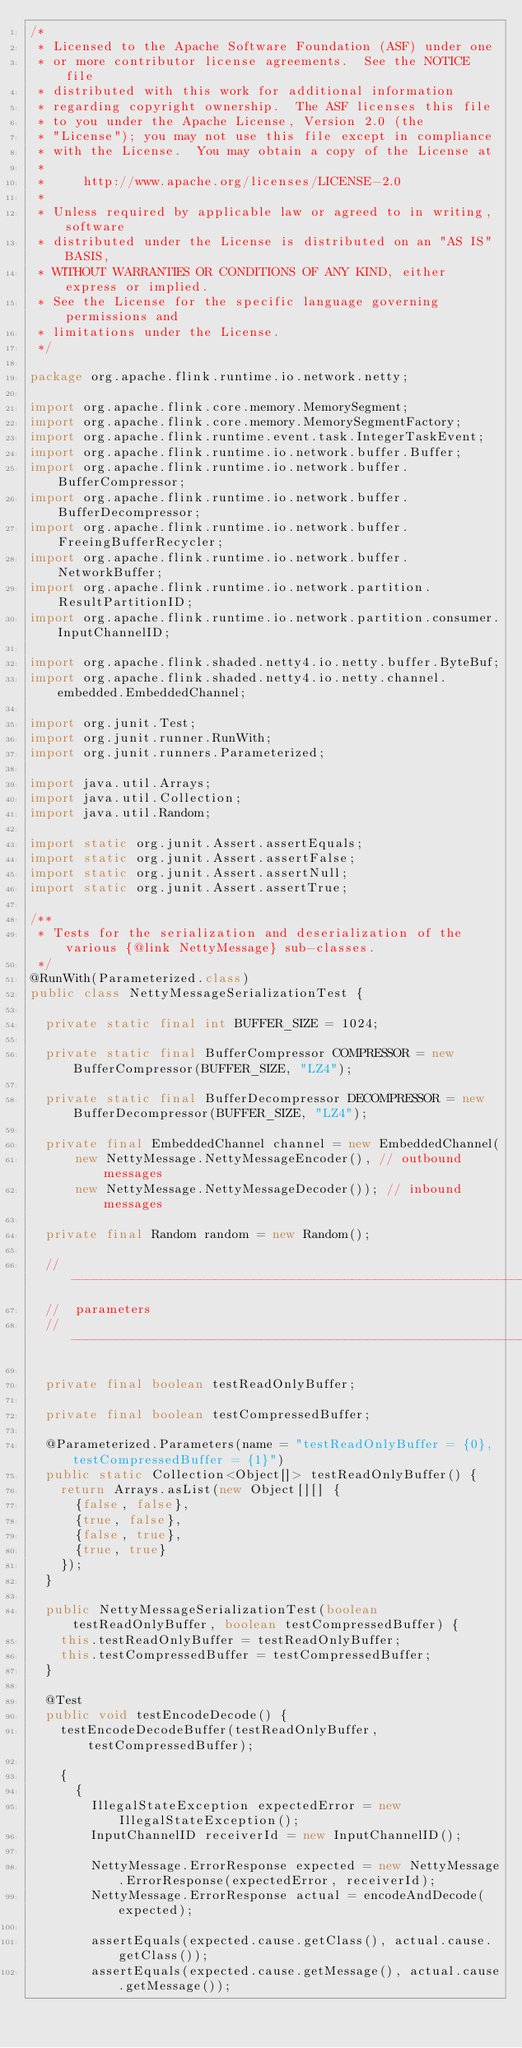<code> <loc_0><loc_0><loc_500><loc_500><_Java_>/*
 * Licensed to the Apache Software Foundation (ASF) under one
 * or more contributor license agreements.  See the NOTICE file
 * distributed with this work for additional information
 * regarding copyright ownership.  The ASF licenses this file
 * to you under the Apache License, Version 2.0 (the
 * "License"); you may not use this file except in compliance
 * with the License.  You may obtain a copy of the License at
 *
 *     http://www.apache.org/licenses/LICENSE-2.0
 *
 * Unless required by applicable law or agreed to in writing, software
 * distributed under the License is distributed on an "AS IS" BASIS,
 * WITHOUT WARRANTIES OR CONDITIONS OF ANY KIND, either express or implied.
 * See the License for the specific language governing permissions and
 * limitations under the License.
 */

package org.apache.flink.runtime.io.network.netty;

import org.apache.flink.core.memory.MemorySegment;
import org.apache.flink.core.memory.MemorySegmentFactory;
import org.apache.flink.runtime.event.task.IntegerTaskEvent;
import org.apache.flink.runtime.io.network.buffer.Buffer;
import org.apache.flink.runtime.io.network.buffer.BufferCompressor;
import org.apache.flink.runtime.io.network.buffer.BufferDecompressor;
import org.apache.flink.runtime.io.network.buffer.FreeingBufferRecycler;
import org.apache.flink.runtime.io.network.buffer.NetworkBuffer;
import org.apache.flink.runtime.io.network.partition.ResultPartitionID;
import org.apache.flink.runtime.io.network.partition.consumer.InputChannelID;

import org.apache.flink.shaded.netty4.io.netty.buffer.ByteBuf;
import org.apache.flink.shaded.netty4.io.netty.channel.embedded.EmbeddedChannel;

import org.junit.Test;
import org.junit.runner.RunWith;
import org.junit.runners.Parameterized;

import java.util.Arrays;
import java.util.Collection;
import java.util.Random;

import static org.junit.Assert.assertEquals;
import static org.junit.Assert.assertFalse;
import static org.junit.Assert.assertNull;
import static org.junit.Assert.assertTrue;

/**
 * Tests for the serialization and deserialization of the various {@link NettyMessage} sub-classes.
 */
@RunWith(Parameterized.class)
public class NettyMessageSerializationTest {

	private static final int BUFFER_SIZE = 1024;

	private static final BufferCompressor COMPRESSOR = new BufferCompressor(BUFFER_SIZE, "LZ4");

	private static final BufferDecompressor DECOMPRESSOR = new BufferDecompressor(BUFFER_SIZE, "LZ4");

	private final EmbeddedChannel channel = new EmbeddedChannel(
			new NettyMessage.NettyMessageEncoder(), // outbound messages
			new NettyMessage.NettyMessageDecoder()); // inbound messages

	private final Random random = new Random();

	// ------------------------------------------------------------------------
	//  parameters
	// ------------------------------------------------------------------------

	private final boolean testReadOnlyBuffer;

	private final boolean testCompressedBuffer;

	@Parameterized.Parameters(name = "testReadOnlyBuffer = {0}, testCompressedBuffer = {1}")
	public static Collection<Object[]> testReadOnlyBuffer() {
		return Arrays.asList(new Object[][] {
			{false, false},
			{true, false},
			{false, true},
			{true, true}
		});
	}

	public NettyMessageSerializationTest(boolean testReadOnlyBuffer, boolean testCompressedBuffer) {
		this.testReadOnlyBuffer = testReadOnlyBuffer;
		this.testCompressedBuffer = testCompressedBuffer;
	}

	@Test
	public void testEncodeDecode() {
		testEncodeDecodeBuffer(testReadOnlyBuffer, testCompressedBuffer);

		{
			{
				IllegalStateException expectedError = new IllegalStateException();
				InputChannelID receiverId = new InputChannelID();

				NettyMessage.ErrorResponse expected = new NettyMessage.ErrorResponse(expectedError, receiverId);
				NettyMessage.ErrorResponse actual = encodeAndDecode(expected);

				assertEquals(expected.cause.getClass(), actual.cause.getClass());
				assertEquals(expected.cause.getMessage(), actual.cause.getMessage());</code> 